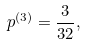Convert formula to latex. <formula><loc_0><loc_0><loc_500><loc_500>p ^ { ( 3 ) } = \frac { 3 } { 3 2 } ,</formula> 